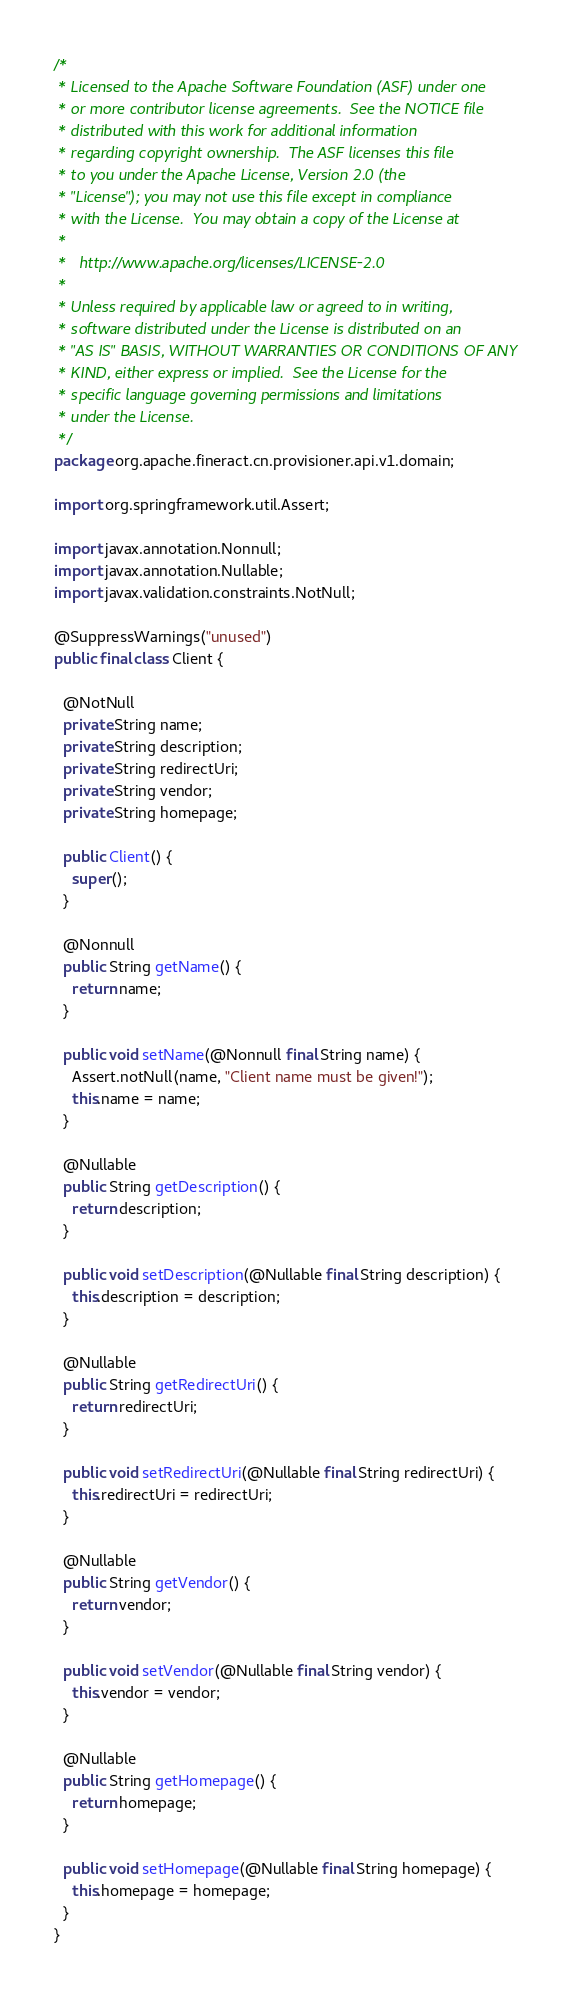<code> <loc_0><loc_0><loc_500><loc_500><_Java_>/*
 * Licensed to the Apache Software Foundation (ASF) under one
 * or more contributor license agreements.  See the NOTICE file
 * distributed with this work for additional information
 * regarding copyright ownership.  The ASF licenses this file
 * to you under the Apache License, Version 2.0 (the
 * "License"); you may not use this file except in compliance
 * with the License.  You may obtain a copy of the License at
 *
 *   http://www.apache.org/licenses/LICENSE-2.0
 *
 * Unless required by applicable law or agreed to in writing,
 * software distributed under the License is distributed on an
 * "AS IS" BASIS, WITHOUT WARRANTIES OR CONDITIONS OF ANY
 * KIND, either express or implied.  See the License for the
 * specific language governing permissions and limitations
 * under the License.
 */
package org.apache.fineract.cn.provisioner.api.v1.domain;

import org.springframework.util.Assert;

import javax.annotation.Nonnull;
import javax.annotation.Nullable;
import javax.validation.constraints.NotNull;

@SuppressWarnings("unused")
public final class Client {

  @NotNull
  private String name;
  private String description;
  private String redirectUri;
  private String vendor;
  private String homepage;

  public Client() {
    super();
  }

  @Nonnull
  public String getName() {
    return name;
  }

  public void setName(@Nonnull final String name) {
    Assert.notNull(name, "Client name must be given!");
    this.name = name;
  }

  @Nullable
  public String getDescription() {
    return description;
  }

  public void setDescription(@Nullable final String description) {
    this.description = description;
  }

  @Nullable
  public String getRedirectUri() {
    return redirectUri;
  }

  public void setRedirectUri(@Nullable final String redirectUri) {
    this.redirectUri = redirectUri;
  }

  @Nullable
  public String getVendor() {
    return vendor;
  }

  public void setVendor(@Nullable final String vendor) {
    this.vendor = vendor;
  }

  @Nullable
  public String getHomepage() {
    return homepage;
  }

  public void setHomepage(@Nullable final String homepage) {
    this.homepage = homepage;
  }
}
</code> 